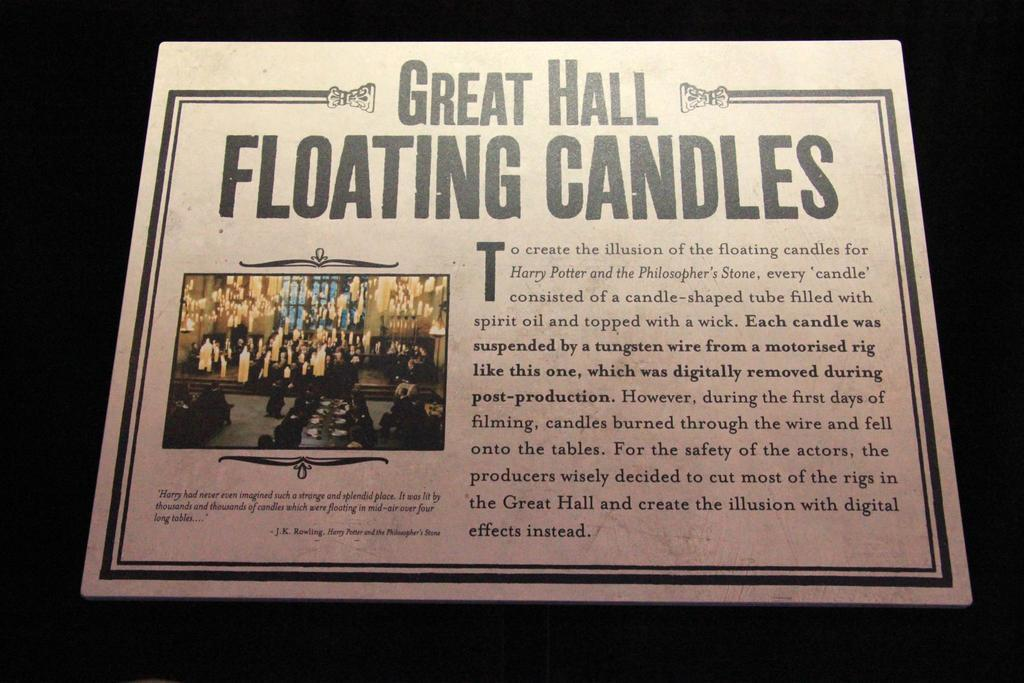<image>
Give a short and clear explanation of the subsequent image. A poster for Great Hall Floating Candles with a picture of people on it. 